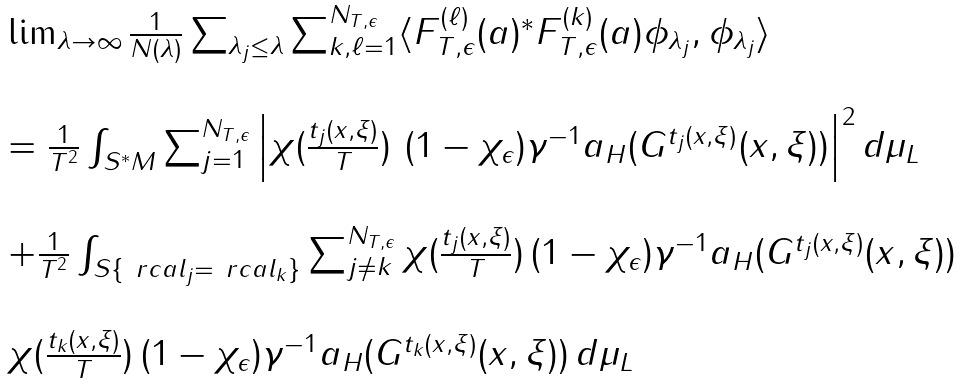Convert formula to latex. <formula><loc_0><loc_0><loc_500><loc_500>\begin{array} { l l } \lim _ { \lambda \rightarrow \infty } \frac { 1 } { N ( \lambda ) } \sum _ { \lambda _ { j } \leq \lambda } \sum _ { k , \ell = 1 } ^ { N _ { T , \epsilon } } \langle F _ { T , \epsilon } ^ { ( \ell ) } ( a ) ^ { * } F _ { T , \epsilon } ^ { ( k ) } ( a ) \phi _ { \lambda _ { j } } , \phi _ { \lambda _ { j } } \rangle \\ \\ = \frac { 1 } { T ^ { 2 } } \int _ { S ^ { * } M } \sum _ { j = 1 } ^ { N _ { T , \epsilon } } \left | \chi ( \frac { t _ { j } ( x , \xi ) } { T } ) \ ( 1 - \chi _ { \epsilon } ) \gamma ^ { - 1 } a _ { H } ( G ^ { t _ { j } ( x , \xi ) } ( x , \xi ) ) \right | ^ { 2 } d \mu _ { L } \\ \\ + \frac { 1 } { T ^ { 2 } } \int _ { S \{ \ r c a l _ { j } = \ r c a l _ { k } \} } \sum _ { j \neq k } ^ { N _ { T , \epsilon } } \chi ( \frac { t _ { j } ( x , \xi ) } { T } ) \, ( 1 - \chi _ { \epsilon } ) \gamma ^ { - 1 } a _ { H } ( G ^ { t _ { j } ( x , \xi ) } ( x , \xi ) ) \\ \\ \chi ( \frac { t _ { k } ( x , \xi ) } { T } ) \, ( 1 - \chi _ { \epsilon } ) \gamma ^ { - 1 } a _ { H } ( G ^ { t _ { k } ( x , \xi ) } ( x , \xi ) ) \, d \mu _ { L } \end{array}</formula> 